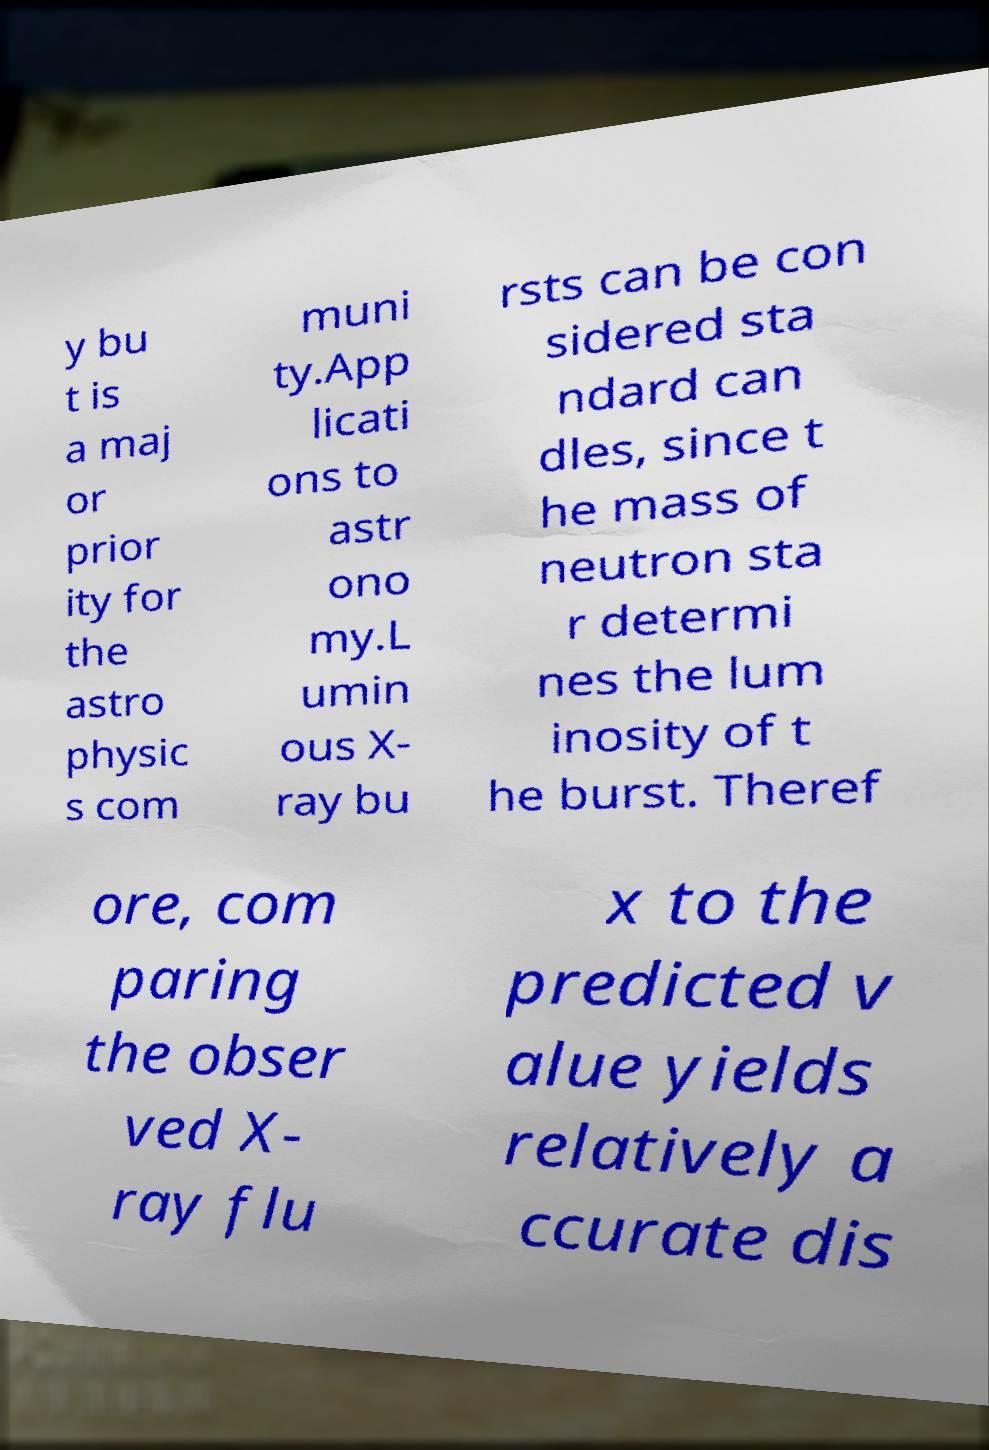Could you extract and type out the text from this image? y bu t is a maj or prior ity for the astro physic s com muni ty.App licati ons to astr ono my.L umin ous X- ray bu rsts can be con sidered sta ndard can dles, since t he mass of neutron sta r determi nes the lum inosity of t he burst. Theref ore, com paring the obser ved X- ray flu x to the predicted v alue yields relatively a ccurate dis 